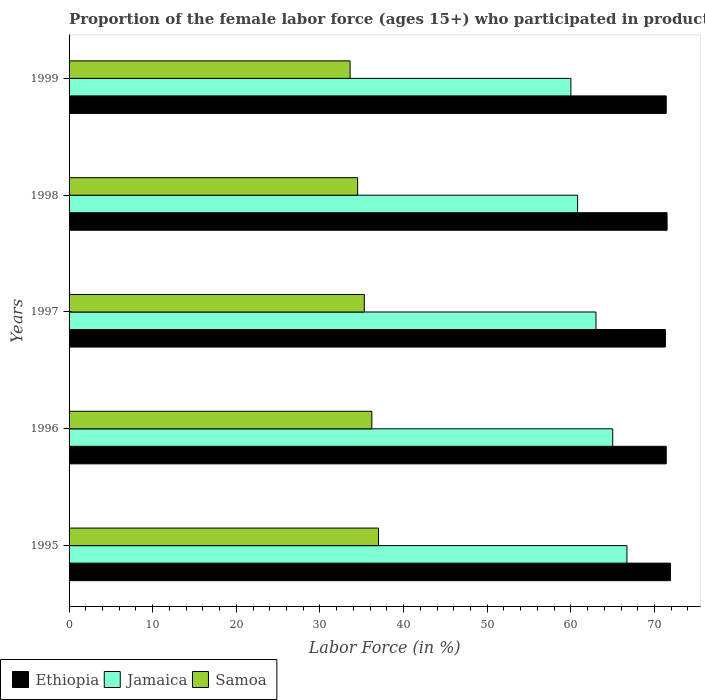How many different coloured bars are there?
Your answer should be compact. 3. How many groups of bars are there?
Provide a succinct answer. 5. Are the number of bars per tick equal to the number of legend labels?
Your answer should be very brief. Yes. Are the number of bars on each tick of the Y-axis equal?
Give a very brief answer. Yes. How many bars are there on the 1st tick from the bottom?
Your answer should be compact. 3. In how many cases, is the number of bars for a given year not equal to the number of legend labels?
Keep it short and to the point. 0. What is the proportion of the female labor force who participated in production in Jamaica in 1995?
Your answer should be very brief. 66.7. Across all years, what is the maximum proportion of the female labor force who participated in production in Jamaica?
Ensure brevity in your answer.  66.7. Across all years, what is the minimum proportion of the female labor force who participated in production in Ethiopia?
Give a very brief answer. 71.3. In which year was the proportion of the female labor force who participated in production in Samoa maximum?
Make the answer very short. 1995. In which year was the proportion of the female labor force who participated in production in Jamaica minimum?
Make the answer very short. 1999. What is the total proportion of the female labor force who participated in production in Ethiopia in the graph?
Offer a terse response. 357.5. What is the difference between the proportion of the female labor force who participated in production in Jamaica in 1995 and that in 1999?
Offer a very short reply. 6.7. What is the difference between the proportion of the female labor force who participated in production in Jamaica in 1995 and the proportion of the female labor force who participated in production in Ethiopia in 1997?
Your answer should be compact. -4.6. What is the average proportion of the female labor force who participated in production in Samoa per year?
Your answer should be compact. 35.32. In the year 1999, what is the difference between the proportion of the female labor force who participated in production in Jamaica and proportion of the female labor force who participated in production in Samoa?
Offer a very short reply. 26.4. What is the ratio of the proportion of the female labor force who participated in production in Ethiopia in 1995 to that in 1999?
Make the answer very short. 1.01. Is the difference between the proportion of the female labor force who participated in production in Jamaica in 1997 and 1999 greater than the difference between the proportion of the female labor force who participated in production in Samoa in 1997 and 1999?
Keep it short and to the point. Yes. What is the difference between the highest and the second highest proportion of the female labor force who participated in production in Samoa?
Your response must be concise. 0.8. What is the difference between the highest and the lowest proportion of the female labor force who participated in production in Jamaica?
Your answer should be very brief. 6.7. Is the sum of the proportion of the female labor force who participated in production in Samoa in 1995 and 1998 greater than the maximum proportion of the female labor force who participated in production in Ethiopia across all years?
Ensure brevity in your answer.  No. What does the 3rd bar from the top in 1997 represents?
Your answer should be very brief. Ethiopia. What does the 3rd bar from the bottom in 1997 represents?
Keep it short and to the point. Samoa. Is it the case that in every year, the sum of the proportion of the female labor force who participated in production in Ethiopia and proportion of the female labor force who participated in production in Samoa is greater than the proportion of the female labor force who participated in production in Jamaica?
Your answer should be very brief. Yes. Are all the bars in the graph horizontal?
Make the answer very short. Yes. What is the difference between two consecutive major ticks on the X-axis?
Provide a short and direct response. 10. Does the graph contain any zero values?
Give a very brief answer. No. Does the graph contain grids?
Give a very brief answer. No. Where does the legend appear in the graph?
Make the answer very short. Bottom left. How many legend labels are there?
Keep it short and to the point. 3. What is the title of the graph?
Your answer should be very brief. Proportion of the female labor force (ages 15+) who participated in production. Does "Guam" appear as one of the legend labels in the graph?
Provide a succinct answer. No. What is the label or title of the Y-axis?
Your response must be concise. Years. What is the Labor Force (in %) of Ethiopia in 1995?
Offer a terse response. 71.9. What is the Labor Force (in %) of Jamaica in 1995?
Offer a terse response. 66.7. What is the Labor Force (in %) in Samoa in 1995?
Your answer should be compact. 37. What is the Labor Force (in %) in Ethiopia in 1996?
Your answer should be very brief. 71.4. What is the Labor Force (in %) in Jamaica in 1996?
Offer a terse response. 65. What is the Labor Force (in %) in Samoa in 1996?
Your response must be concise. 36.2. What is the Labor Force (in %) of Ethiopia in 1997?
Give a very brief answer. 71.3. What is the Labor Force (in %) in Jamaica in 1997?
Provide a succinct answer. 63. What is the Labor Force (in %) of Samoa in 1997?
Give a very brief answer. 35.3. What is the Labor Force (in %) of Ethiopia in 1998?
Make the answer very short. 71.5. What is the Labor Force (in %) of Jamaica in 1998?
Make the answer very short. 60.8. What is the Labor Force (in %) in Samoa in 1998?
Your answer should be compact. 34.5. What is the Labor Force (in %) of Ethiopia in 1999?
Keep it short and to the point. 71.4. What is the Labor Force (in %) of Samoa in 1999?
Give a very brief answer. 33.6. Across all years, what is the maximum Labor Force (in %) of Ethiopia?
Provide a succinct answer. 71.9. Across all years, what is the maximum Labor Force (in %) of Jamaica?
Offer a terse response. 66.7. Across all years, what is the minimum Labor Force (in %) in Ethiopia?
Offer a very short reply. 71.3. Across all years, what is the minimum Labor Force (in %) of Samoa?
Provide a succinct answer. 33.6. What is the total Labor Force (in %) in Ethiopia in the graph?
Your answer should be very brief. 357.5. What is the total Labor Force (in %) of Jamaica in the graph?
Your answer should be compact. 315.5. What is the total Labor Force (in %) in Samoa in the graph?
Your answer should be very brief. 176.6. What is the difference between the Labor Force (in %) in Jamaica in 1995 and that in 1996?
Your answer should be compact. 1.7. What is the difference between the Labor Force (in %) in Samoa in 1995 and that in 1996?
Ensure brevity in your answer.  0.8. What is the difference between the Labor Force (in %) of Jamaica in 1995 and that in 1997?
Make the answer very short. 3.7. What is the difference between the Labor Force (in %) of Samoa in 1995 and that in 1997?
Give a very brief answer. 1.7. What is the difference between the Labor Force (in %) in Jamaica in 1995 and that in 1998?
Make the answer very short. 5.9. What is the difference between the Labor Force (in %) in Ethiopia in 1995 and that in 1999?
Offer a very short reply. 0.5. What is the difference between the Labor Force (in %) in Jamaica in 1996 and that in 1997?
Your response must be concise. 2. What is the difference between the Labor Force (in %) of Samoa in 1996 and that in 1997?
Your answer should be very brief. 0.9. What is the difference between the Labor Force (in %) of Ethiopia in 1996 and that in 1998?
Your answer should be compact. -0.1. What is the difference between the Labor Force (in %) in Samoa in 1996 and that in 1998?
Your answer should be compact. 1.7. What is the difference between the Labor Force (in %) in Jamaica in 1996 and that in 1999?
Offer a very short reply. 5. What is the difference between the Labor Force (in %) in Ethiopia in 1997 and that in 1998?
Your answer should be compact. -0.2. What is the difference between the Labor Force (in %) in Ethiopia in 1997 and that in 1999?
Your answer should be very brief. -0.1. What is the difference between the Labor Force (in %) of Jamaica in 1997 and that in 1999?
Ensure brevity in your answer.  3. What is the difference between the Labor Force (in %) of Ethiopia in 1998 and that in 1999?
Offer a terse response. 0.1. What is the difference between the Labor Force (in %) of Samoa in 1998 and that in 1999?
Offer a terse response. 0.9. What is the difference between the Labor Force (in %) in Ethiopia in 1995 and the Labor Force (in %) in Samoa in 1996?
Make the answer very short. 35.7. What is the difference between the Labor Force (in %) in Jamaica in 1995 and the Labor Force (in %) in Samoa in 1996?
Your answer should be very brief. 30.5. What is the difference between the Labor Force (in %) of Ethiopia in 1995 and the Labor Force (in %) of Samoa in 1997?
Make the answer very short. 36.6. What is the difference between the Labor Force (in %) of Jamaica in 1995 and the Labor Force (in %) of Samoa in 1997?
Offer a terse response. 31.4. What is the difference between the Labor Force (in %) in Ethiopia in 1995 and the Labor Force (in %) in Jamaica in 1998?
Provide a succinct answer. 11.1. What is the difference between the Labor Force (in %) of Ethiopia in 1995 and the Labor Force (in %) of Samoa in 1998?
Give a very brief answer. 37.4. What is the difference between the Labor Force (in %) of Jamaica in 1995 and the Labor Force (in %) of Samoa in 1998?
Keep it short and to the point. 32.2. What is the difference between the Labor Force (in %) of Ethiopia in 1995 and the Labor Force (in %) of Samoa in 1999?
Keep it short and to the point. 38.3. What is the difference between the Labor Force (in %) in Jamaica in 1995 and the Labor Force (in %) in Samoa in 1999?
Provide a succinct answer. 33.1. What is the difference between the Labor Force (in %) in Ethiopia in 1996 and the Labor Force (in %) in Jamaica in 1997?
Keep it short and to the point. 8.4. What is the difference between the Labor Force (in %) in Ethiopia in 1996 and the Labor Force (in %) in Samoa in 1997?
Offer a very short reply. 36.1. What is the difference between the Labor Force (in %) of Jamaica in 1996 and the Labor Force (in %) of Samoa in 1997?
Your answer should be very brief. 29.7. What is the difference between the Labor Force (in %) in Ethiopia in 1996 and the Labor Force (in %) in Samoa in 1998?
Your answer should be compact. 36.9. What is the difference between the Labor Force (in %) of Jamaica in 1996 and the Labor Force (in %) of Samoa in 1998?
Provide a short and direct response. 30.5. What is the difference between the Labor Force (in %) in Ethiopia in 1996 and the Labor Force (in %) in Samoa in 1999?
Your answer should be compact. 37.8. What is the difference between the Labor Force (in %) in Jamaica in 1996 and the Labor Force (in %) in Samoa in 1999?
Your response must be concise. 31.4. What is the difference between the Labor Force (in %) of Ethiopia in 1997 and the Labor Force (in %) of Jamaica in 1998?
Make the answer very short. 10.5. What is the difference between the Labor Force (in %) of Ethiopia in 1997 and the Labor Force (in %) of Samoa in 1998?
Your answer should be very brief. 36.8. What is the difference between the Labor Force (in %) of Ethiopia in 1997 and the Labor Force (in %) of Jamaica in 1999?
Offer a terse response. 11.3. What is the difference between the Labor Force (in %) in Ethiopia in 1997 and the Labor Force (in %) in Samoa in 1999?
Make the answer very short. 37.7. What is the difference between the Labor Force (in %) of Jamaica in 1997 and the Labor Force (in %) of Samoa in 1999?
Your answer should be very brief. 29.4. What is the difference between the Labor Force (in %) in Ethiopia in 1998 and the Labor Force (in %) in Samoa in 1999?
Offer a very short reply. 37.9. What is the difference between the Labor Force (in %) of Jamaica in 1998 and the Labor Force (in %) of Samoa in 1999?
Your response must be concise. 27.2. What is the average Labor Force (in %) of Ethiopia per year?
Your response must be concise. 71.5. What is the average Labor Force (in %) in Jamaica per year?
Provide a short and direct response. 63.1. What is the average Labor Force (in %) of Samoa per year?
Give a very brief answer. 35.32. In the year 1995, what is the difference between the Labor Force (in %) of Ethiopia and Labor Force (in %) of Jamaica?
Provide a succinct answer. 5.2. In the year 1995, what is the difference between the Labor Force (in %) of Ethiopia and Labor Force (in %) of Samoa?
Provide a succinct answer. 34.9. In the year 1995, what is the difference between the Labor Force (in %) of Jamaica and Labor Force (in %) of Samoa?
Your answer should be very brief. 29.7. In the year 1996, what is the difference between the Labor Force (in %) in Ethiopia and Labor Force (in %) in Jamaica?
Make the answer very short. 6.4. In the year 1996, what is the difference between the Labor Force (in %) of Ethiopia and Labor Force (in %) of Samoa?
Provide a succinct answer. 35.2. In the year 1996, what is the difference between the Labor Force (in %) in Jamaica and Labor Force (in %) in Samoa?
Make the answer very short. 28.8. In the year 1997, what is the difference between the Labor Force (in %) of Ethiopia and Labor Force (in %) of Samoa?
Make the answer very short. 36. In the year 1997, what is the difference between the Labor Force (in %) of Jamaica and Labor Force (in %) of Samoa?
Your answer should be compact. 27.7. In the year 1998, what is the difference between the Labor Force (in %) in Ethiopia and Labor Force (in %) in Jamaica?
Offer a terse response. 10.7. In the year 1998, what is the difference between the Labor Force (in %) of Ethiopia and Labor Force (in %) of Samoa?
Your answer should be very brief. 37. In the year 1998, what is the difference between the Labor Force (in %) in Jamaica and Labor Force (in %) in Samoa?
Your answer should be very brief. 26.3. In the year 1999, what is the difference between the Labor Force (in %) of Ethiopia and Labor Force (in %) of Samoa?
Your answer should be compact. 37.8. In the year 1999, what is the difference between the Labor Force (in %) of Jamaica and Labor Force (in %) of Samoa?
Offer a very short reply. 26.4. What is the ratio of the Labor Force (in %) in Ethiopia in 1995 to that in 1996?
Give a very brief answer. 1.01. What is the ratio of the Labor Force (in %) in Jamaica in 1995 to that in 1996?
Offer a terse response. 1.03. What is the ratio of the Labor Force (in %) of Samoa in 1995 to that in 1996?
Keep it short and to the point. 1.02. What is the ratio of the Labor Force (in %) in Ethiopia in 1995 to that in 1997?
Offer a very short reply. 1.01. What is the ratio of the Labor Force (in %) of Jamaica in 1995 to that in 1997?
Give a very brief answer. 1.06. What is the ratio of the Labor Force (in %) in Samoa in 1995 to that in 1997?
Provide a succinct answer. 1.05. What is the ratio of the Labor Force (in %) of Ethiopia in 1995 to that in 1998?
Your response must be concise. 1.01. What is the ratio of the Labor Force (in %) of Jamaica in 1995 to that in 1998?
Offer a terse response. 1.1. What is the ratio of the Labor Force (in %) of Samoa in 1995 to that in 1998?
Give a very brief answer. 1.07. What is the ratio of the Labor Force (in %) in Jamaica in 1995 to that in 1999?
Offer a very short reply. 1.11. What is the ratio of the Labor Force (in %) in Samoa in 1995 to that in 1999?
Offer a very short reply. 1.1. What is the ratio of the Labor Force (in %) of Jamaica in 1996 to that in 1997?
Keep it short and to the point. 1.03. What is the ratio of the Labor Force (in %) in Samoa in 1996 to that in 1997?
Provide a short and direct response. 1.03. What is the ratio of the Labor Force (in %) in Ethiopia in 1996 to that in 1998?
Provide a succinct answer. 1. What is the ratio of the Labor Force (in %) in Jamaica in 1996 to that in 1998?
Your response must be concise. 1.07. What is the ratio of the Labor Force (in %) of Samoa in 1996 to that in 1998?
Keep it short and to the point. 1.05. What is the ratio of the Labor Force (in %) in Ethiopia in 1996 to that in 1999?
Your answer should be very brief. 1. What is the ratio of the Labor Force (in %) of Jamaica in 1996 to that in 1999?
Give a very brief answer. 1.08. What is the ratio of the Labor Force (in %) in Samoa in 1996 to that in 1999?
Offer a very short reply. 1.08. What is the ratio of the Labor Force (in %) in Jamaica in 1997 to that in 1998?
Your response must be concise. 1.04. What is the ratio of the Labor Force (in %) in Samoa in 1997 to that in 1998?
Offer a terse response. 1.02. What is the ratio of the Labor Force (in %) in Ethiopia in 1997 to that in 1999?
Make the answer very short. 1. What is the ratio of the Labor Force (in %) in Samoa in 1997 to that in 1999?
Offer a terse response. 1.05. What is the ratio of the Labor Force (in %) in Ethiopia in 1998 to that in 1999?
Your answer should be compact. 1. What is the ratio of the Labor Force (in %) of Jamaica in 1998 to that in 1999?
Offer a terse response. 1.01. What is the ratio of the Labor Force (in %) in Samoa in 1998 to that in 1999?
Offer a very short reply. 1.03. What is the difference between the highest and the second highest Labor Force (in %) in Samoa?
Offer a very short reply. 0.8. 